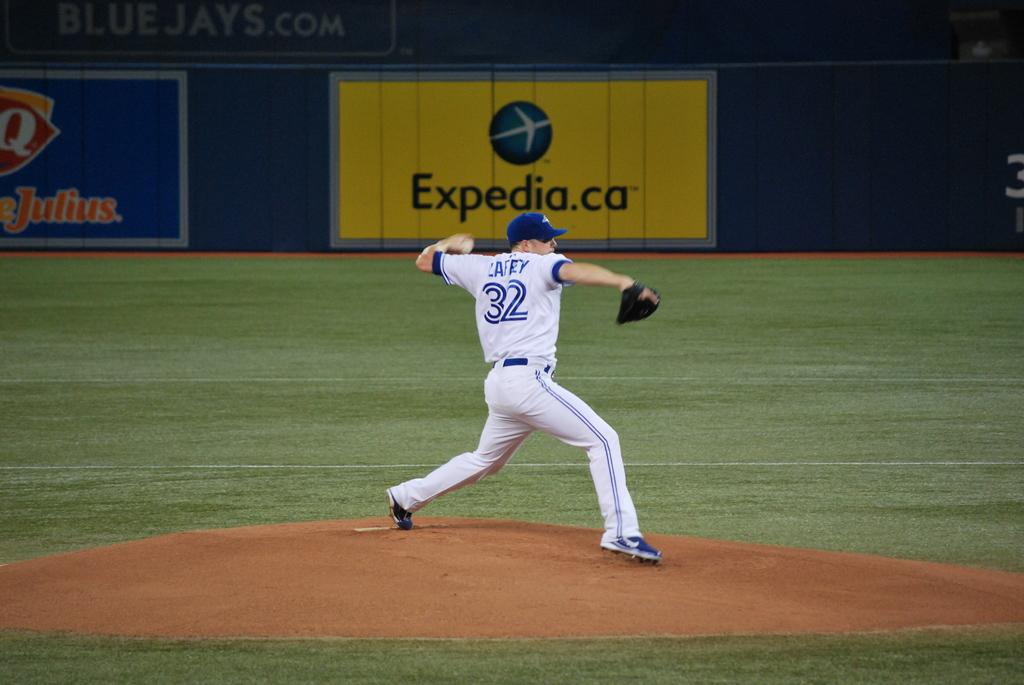<image>
Relay a brief, clear account of the picture shown. Ball park with a large yellow marquee that has Expedia.ca on it in black. 